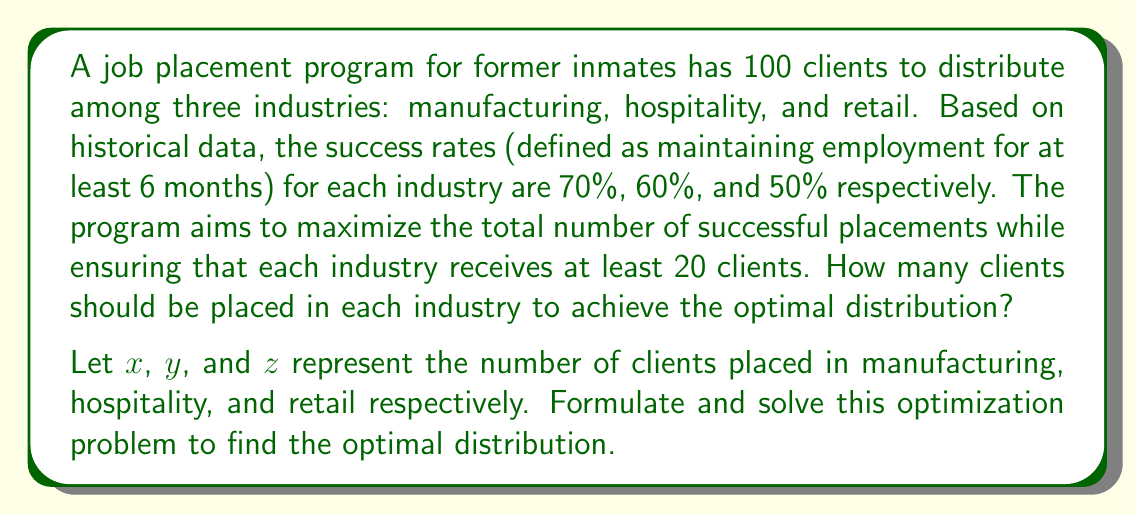What is the answer to this math problem? To solve this optimization problem, we'll follow these steps:

1. Set up the objective function:
   We want to maximize the total number of successful placements.
   $$\text{Maximize: } f(x,y,z) = 0.7x + 0.6y + 0.5z$$

2. Define the constraints:
   a) Total number of clients: $x + y + z = 100$
   b) Minimum clients per industry: $x \geq 20$, $y \geq 20$, $z \geq 20$
   c) Non-negativity: $x, y, z \geq 0$

3. Solve using the method of Lagrange multipliers:
   $$L(x,y,z,\lambda) = 0.7x + 0.6y + 0.5z - \lambda(x + y + z - 100)$$

4. Set partial derivatives to zero:
   $$\frac{\partial L}{\partial x} = 0.7 - \lambda = 0$$
   $$\frac{\partial L}{\partial y} = 0.6 - \lambda = 0$$
   $$\frac{\partial L}{\partial z} = 0.5 - \lambda = 0$$
   $$\frac{\partial L}{\partial \lambda} = x + y + z - 100 = 0$$

5. From these equations, we can see that $\lambda = 0.7$, which means $x$ should be maximized.

6. Given the constraints, the optimal solution is:
   $x = 60$ (maximum possible while satisfying other constraints)
   $y = 20$ (minimum required)
   $z = 20$ (minimum required)

This distribution satisfies all constraints and maximizes the objective function.
Answer: Manufacturing: 60, Hospitality: 20, Retail: 20 